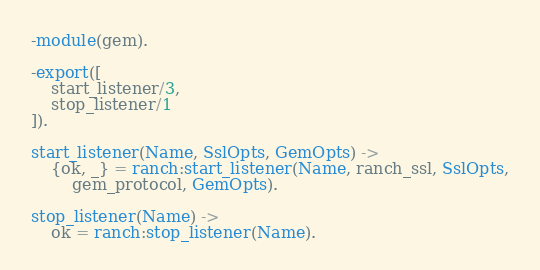<code> <loc_0><loc_0><loc_500><loc_500><_Erlang_>-module(gem).

-export([
    start_listener/3,
    stop_listener/1
]).

start_listener(Name, SslOpts, GemOpts) ->
    {ok, _} = ranch:start_listener(Name, ranch_ssl, SslOpts,
        gem_protocol, GemOpts).

stop_listener(Name) ->
    ok = ranch:stop_listener(Name).
</code> 